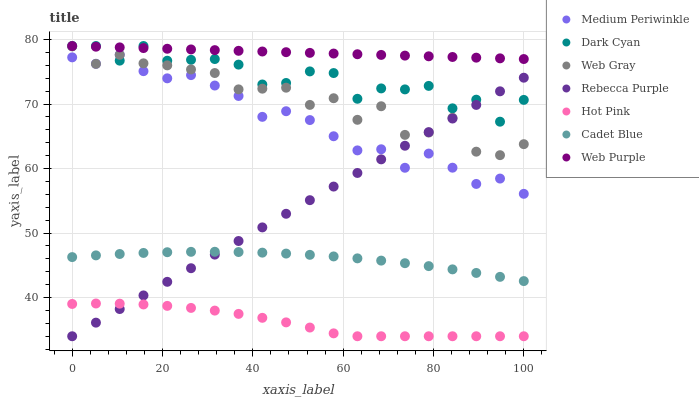Does Hot Pink have the minimum area under the curve?
Answer yes or no. Yes. Does Web Purple have the maximum area under the curve?
Answer yes or no. Yes. Does Medium Periwinkle have the minimum area under the curve?
Answer yes or no. No. Does Medium Periwinkle have the maximum area under the curve?
Answer yes or no. No. Is Rebecca Purple the smoothest?
Answer yes or no. Yes. Is Web Gray the roughest?
Answer yes or no. Yes. Is Hot Pink the smoothest?
Answer yes or no. No. Is Hot Pink the roughest?
Answer yes or no. No. Does Hot Pink have the lowest value?
Answer yes or no. Yes. Does Medium Periwinkle have the lowest value?
Answer yes or no. No. Does Dark Cyan have the highest value?
Answer yes or no. Yes. Does Medium Periwinkle have the highest value?
Answer yes or no. No. Is Medium Periwinkle less than Web Purple?
Answer yes or no. Yes. Is Web Purple greater than Medium Periwinkle?
Answer yes or no. Yes. Does Web Gray intersect Dark Cyan?
Answer yes or no. Yes. Is Web Gray less than Dark Cyan?
Answer yes or no. No. Is Web Gray greater than Dark Cyan?
Answer yes or no. No. Does Medium Periwinkle intersect Web Purple?
Answer yes or no. No. 